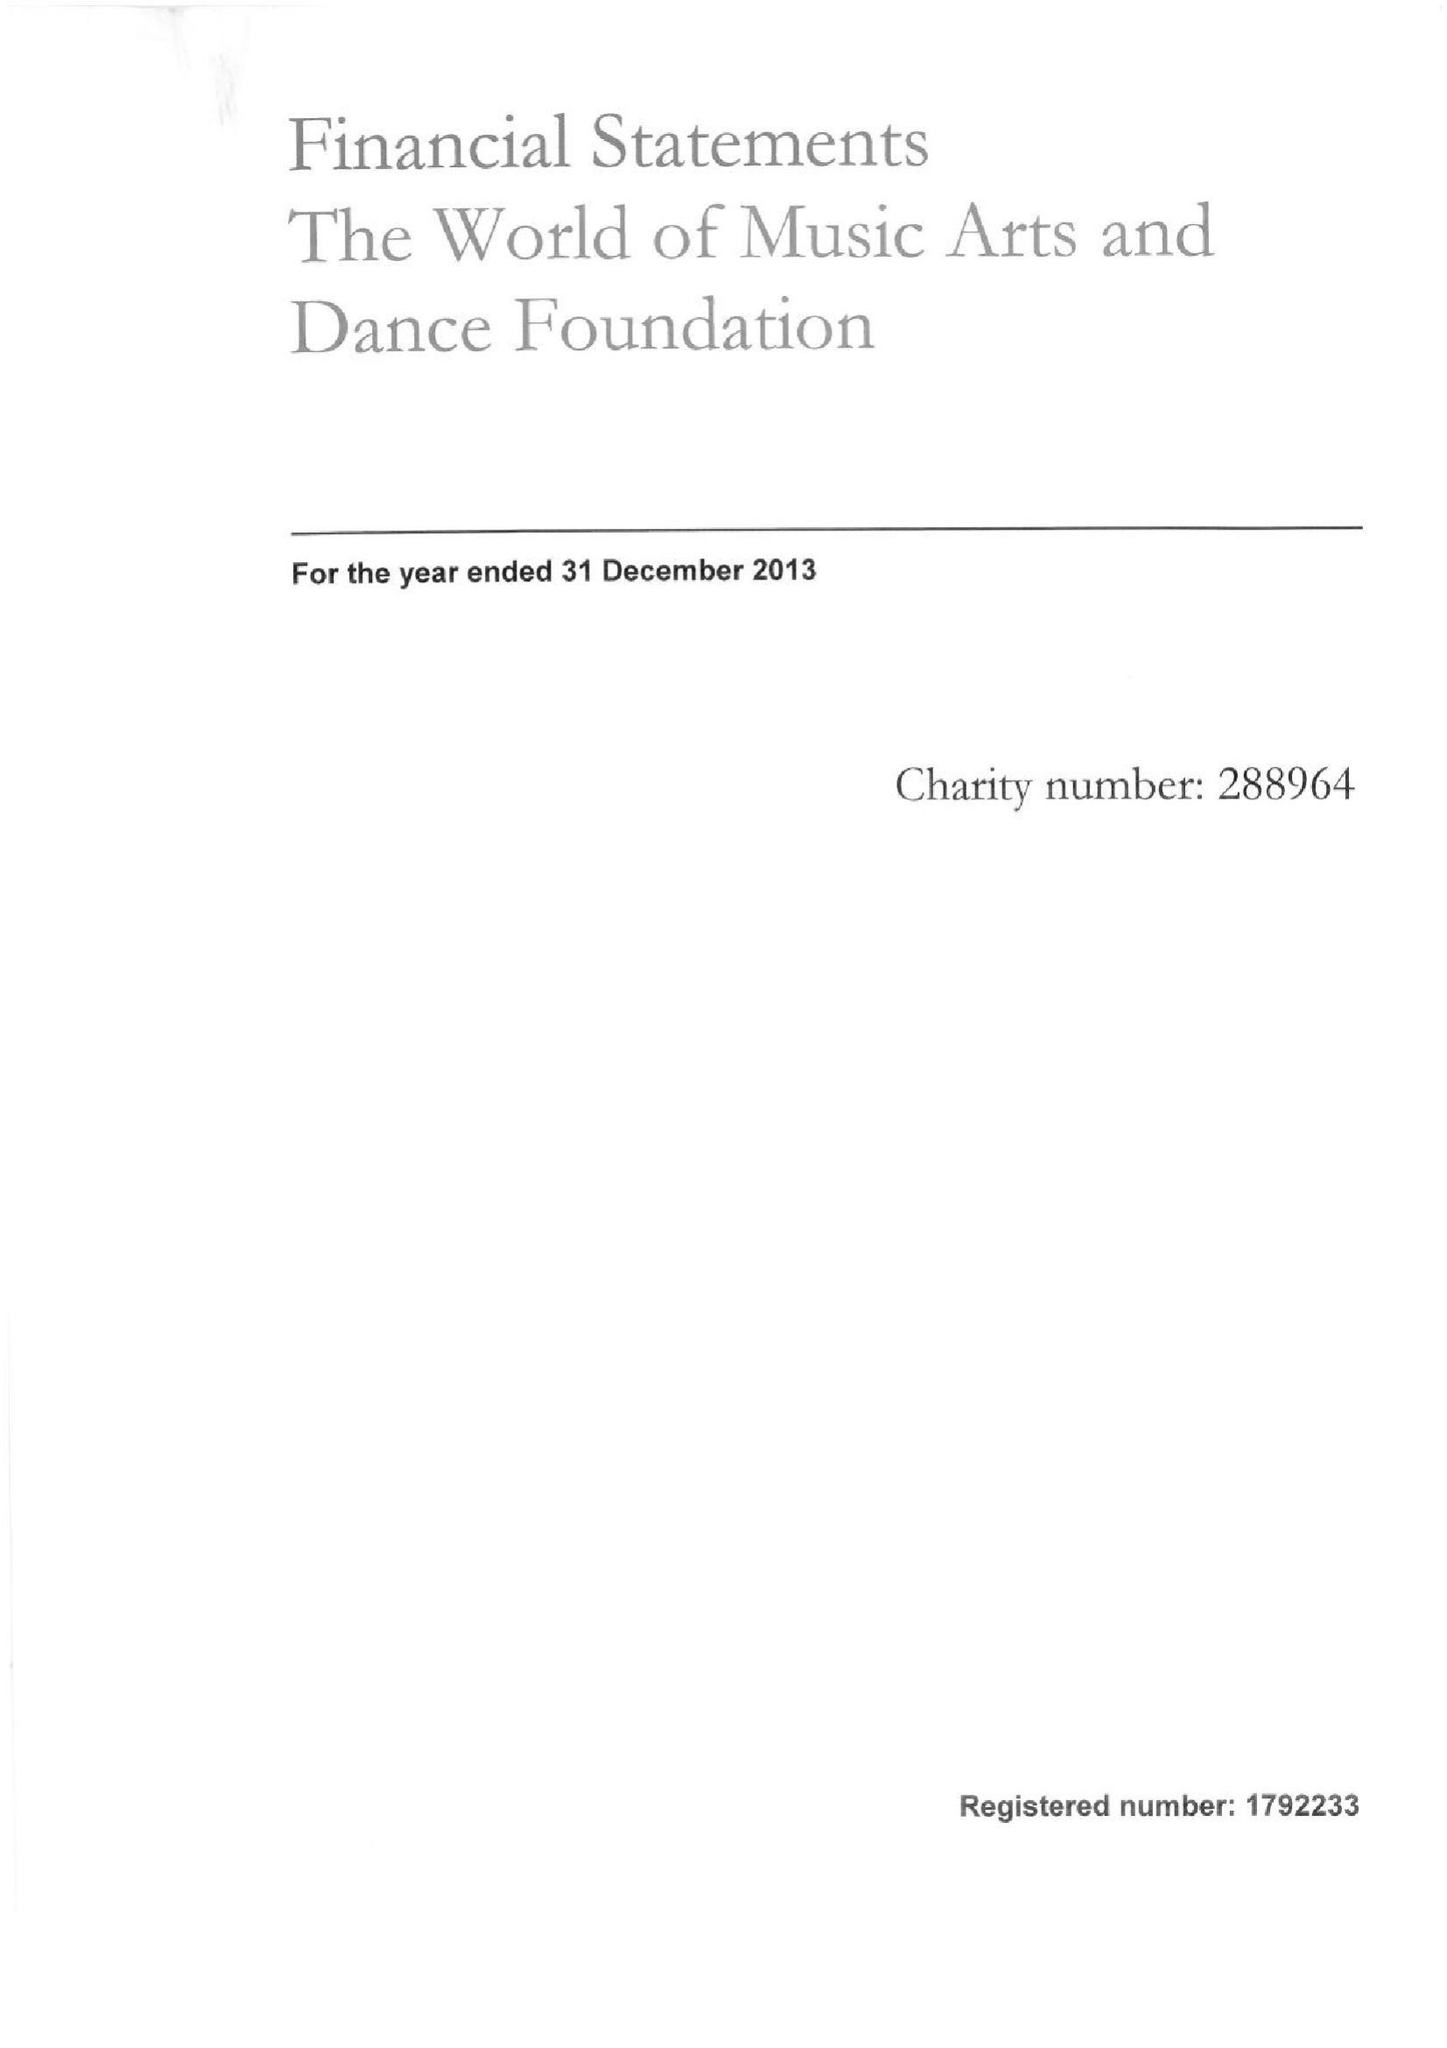What is the value for the address__post_town?
Answer the question using a single word or phrase. CORSHAM 